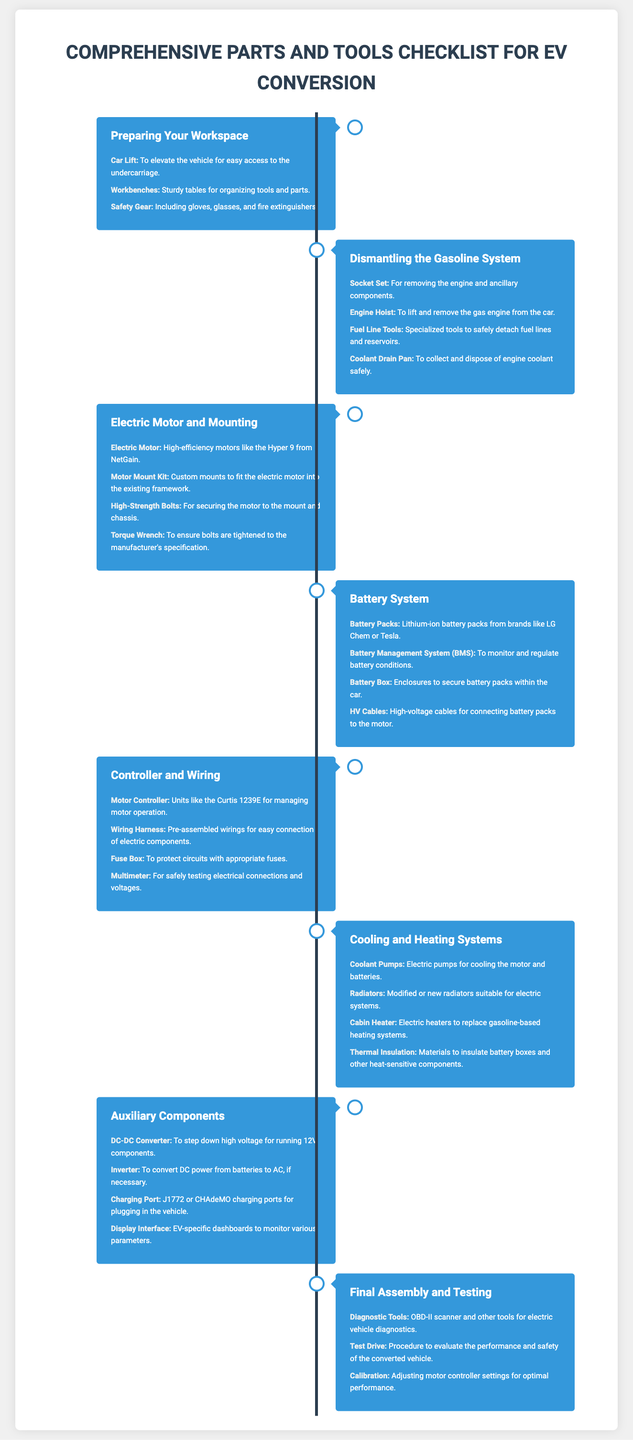What is the first section in the checklist? The first section listed in the document is "Preparing Your Workspace."
Answer: Preparing Your Workspace What tool is used to lift the gas engine from the car? The document mentions an "Engine Hoist" for lifting and removing the gas engine.
Answer: Engine Hoist What type of motor is specified for the electric conversion? The document specifies using high-efficiency motors like the "Hyper 9 from NetGain."
Answer: Hyper 9 from NetGain Which component is necessary for monitoring battery conditions? The "Battery Management System (BMS)" is necessary for monitoring and regulating battery conditions.
Answer: Battery Management System (BMS) How many main sections are there in the document? The document includes a total of seven main sections listed in the checklist.
Answer: Seven What type of converter is mentioned for running 12V components? The document mentions a "DC-DC Converter" for stepping down high voltage for 12V components.
Answer: DC-DC Converter What is the purpose of the Diagnostic Tools listed in the last section? Diagnostic Tools are used for electric vehicle diagnostics and performance evaluation.
Answer: Electric vehicle diagnostics What is the last step mentioned in the process before final assembly? The last step mentioned is "Calibration," which involves adjusting motor controller settings.
Answer: Calibration 